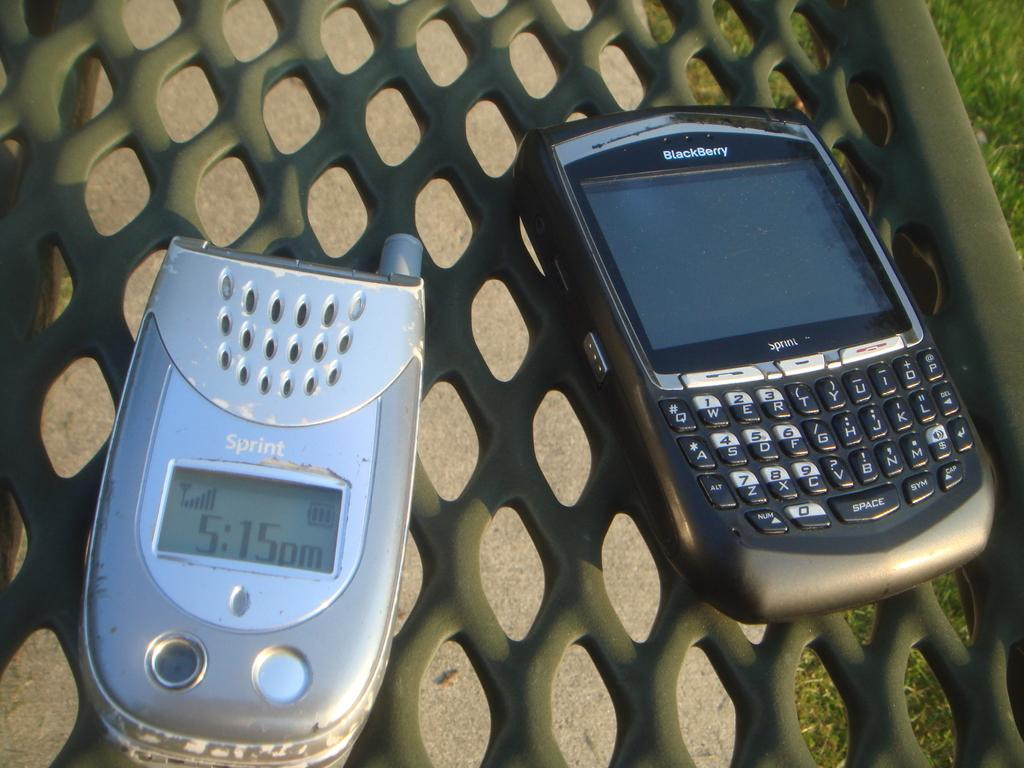<image>
Summarize the visual content of the image. A sprint cell phone and a Blackberry device. 